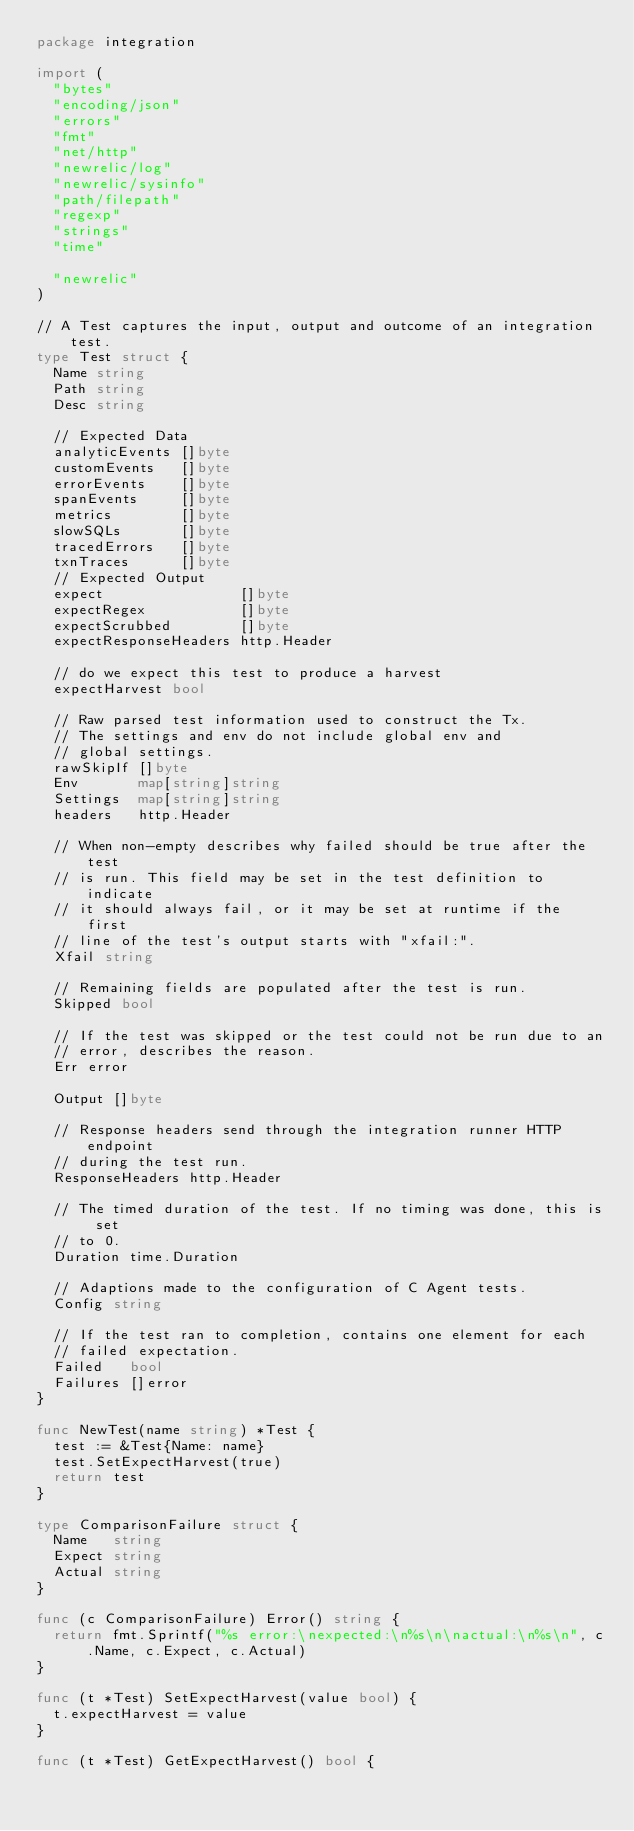<code> <loc_0><loc_0><loc_500><loc_500><_Go_>package integration

import (
	"bytes"
	"encoding/json"
	"errors"
	"fmt"
	"net/http"
	"newrelic/log"
	"newrelic/sysinfo"
	"path/filepath"
	"regexp"
	"strings"
	"time"

	"newrelic"
)

// A Test captures the input, output and outcome of an integration test.
type Test struct {
	Name string
	Path string
	Desc string

	// Expected Data
	analyticEvents []byte
	customEvents   []byte
	errorEvents    []byte
	spanEvents     []byte
	metrics        []byte
	slowSQLs       []byte
	tracedErrors   []byte
	txnTraces      []byte
	// Expected Output
	expect                []byte
	expectRegex           []byte
	expectScrubbed        []byte
	expectResponseHeaders http.Header

	// do we expect this test to produce a harvest
	expectHarvest bool

	// Raw parsed test information used to construct the Tx.
	// The settings and env do not include global env and
	// global settings.
	rawSkipIf []byte
	Env       map[string]string
	Settings  map[string]string
	headers   http.Header

	// When non-empty describes why failed should be true after the test
	// is run. This field may be set in the test definition to indicate
	// it should always fail, or it may be set at runtime if the first
	// line of the test's output starts with "xfail:".
	Xfail string

	// Remaining fields are populated after the test is run.
	Skipped bool

	// If the test was skipped or the test could not be run due to an
	// error, describes the reason.
	Err error

	Output []byte

	// Response headers send through the integration runner HTTP endpoint
	// during the test run.
	ResponseHeaders http.Header

	// The timed duration of the test. If no timing was done, this is set
	// to 0.
	Duration time.Duration

	// Adaptions made to the configuration of C Agent tests.
	Config string

	// If the test ran to completion, contains one element for each
	// failed expectation.
	Failed   bool
	Failures []error
}

func NewTest(name string) *Test {
	test := &Test{Name: name}
	test.SetExpectHarvest(true)
	return test
}

type ComparisonFailure struct {
	Name   string
	Expect string
	Actual string
}

func (c ComparisonFailure) Error() string {
	return fmt.Sprintf("%s error:\nexpected:\n%s\n\nactual:\n%s\n", c.Name, c.Expect, c.Actual)
}

func (t *Test) SetExpectHarvest(value bool) {
	t.expectHarvest = value
}

func (t *Test) GetExpectHarvest() bool {</code> 